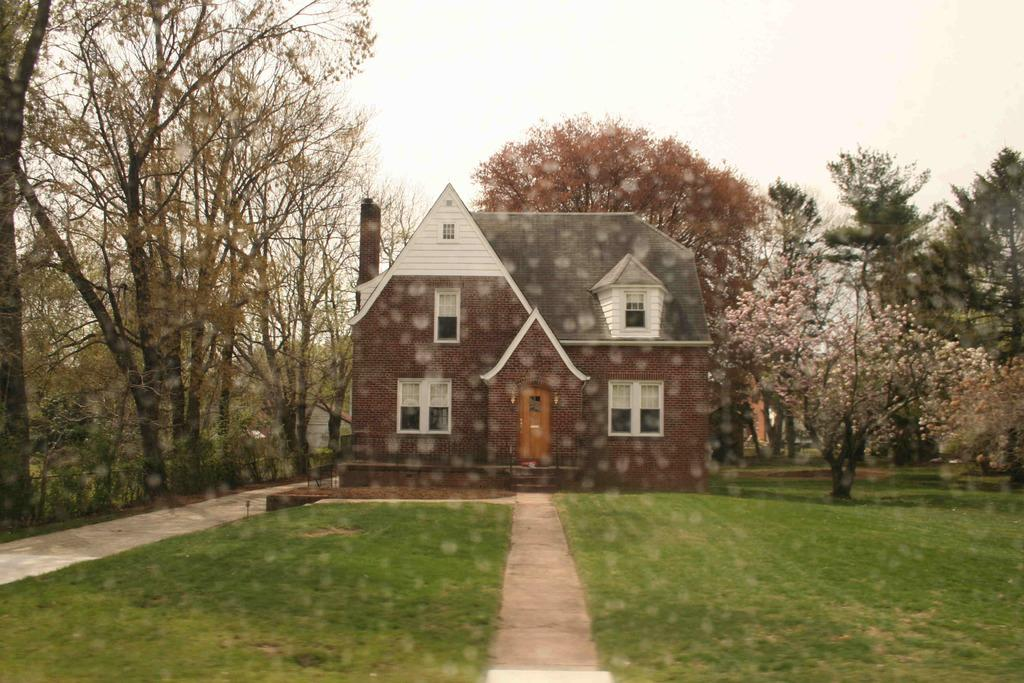What is the main structure in the picture? There is a house in the picture. What type of vegetation surrounds the house? There are trees around the house. What type of ground cover is in front of the house? There is grass in front of the house. What type of berry is growing on the roof of the house in the image? There is no berry growing on the roof of the house in the image. 